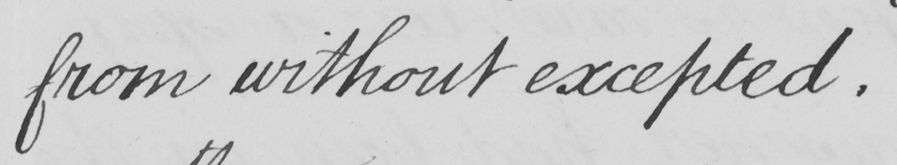What text is written in this handwritten line? from without excepted . 